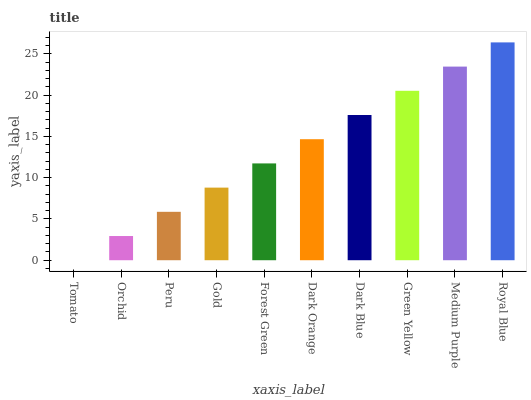Is Orchid the minimum?
Answer yes or no. No. Is Orchid the maximum?
Answer yes or no. No. Is Orchid greater than Tomato?
Answer yes or no. Yes. Is Tomato less than Orchid?
Answer yes or no. Yes. Is Tomato greater than Orchid?
Answer yes or no. No. Is Orchid less than Tomato?
Answer yes or no. No. Is Dark Orange the high median?
Answer yes or no. Yes. Is Forest Green the low median?
Answer yes or no. Yes. Is Green Yellow the high median?
Answer yes or no. No. Is Green Yellow the low median?
Answer yes or no. No. 